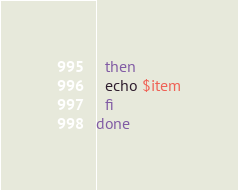Convert code to text. <code><loc_0><loc_0><loc_500><loc_500><_Bash_>  then
  echo $item
  fi
done
</code> 